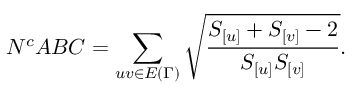Convert formula to latex. <formula><loc_0><loc_0><loc_500><loc_500>N ^ { c } A B C = \sum _ { u v \in E { ( \Gamma ) } } \sqrt { \frac { S _ { [ u ] } + S _ { [ v ] } - 2 } { S _ { [ u ] } S _ { [ v ] } } } .</formula> 